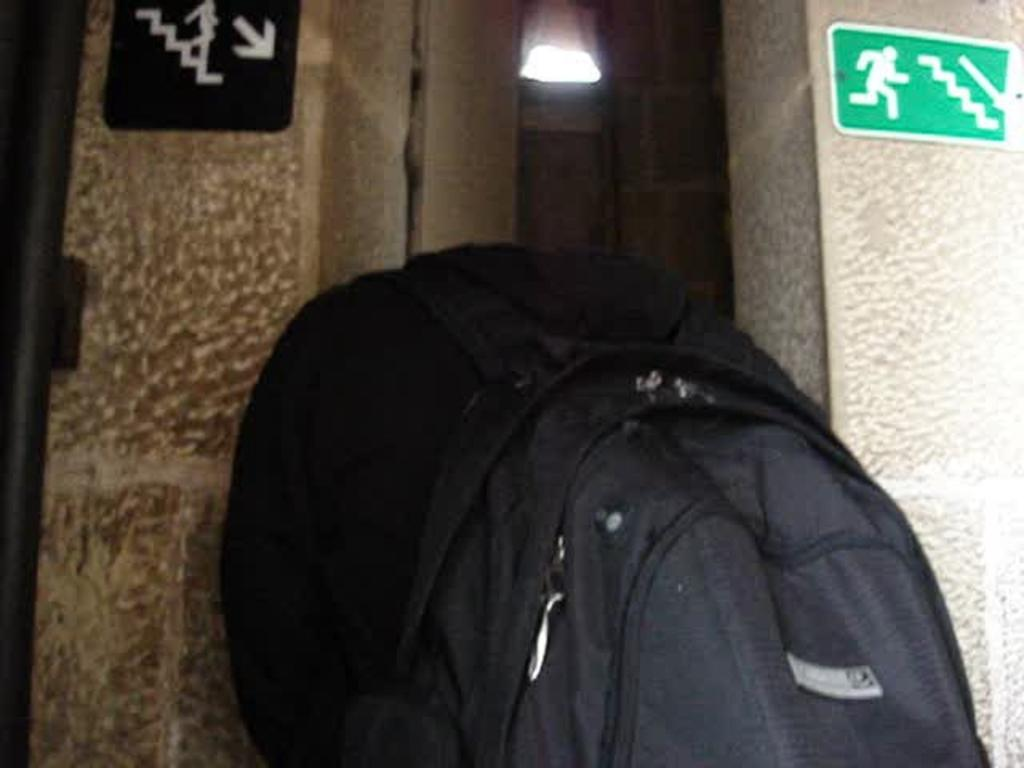What color is the bag in the image? The bag in the image is black. Where is the bag located in relation to other objects in the image? The bag is beside a wall. What additional information can be found in the image? There is a caution board in the right top corner of the image. What type of songs can be heard coming from the bag in the image? There are no songs coming from the bag in the image, as it is a bag and not a musical device. 